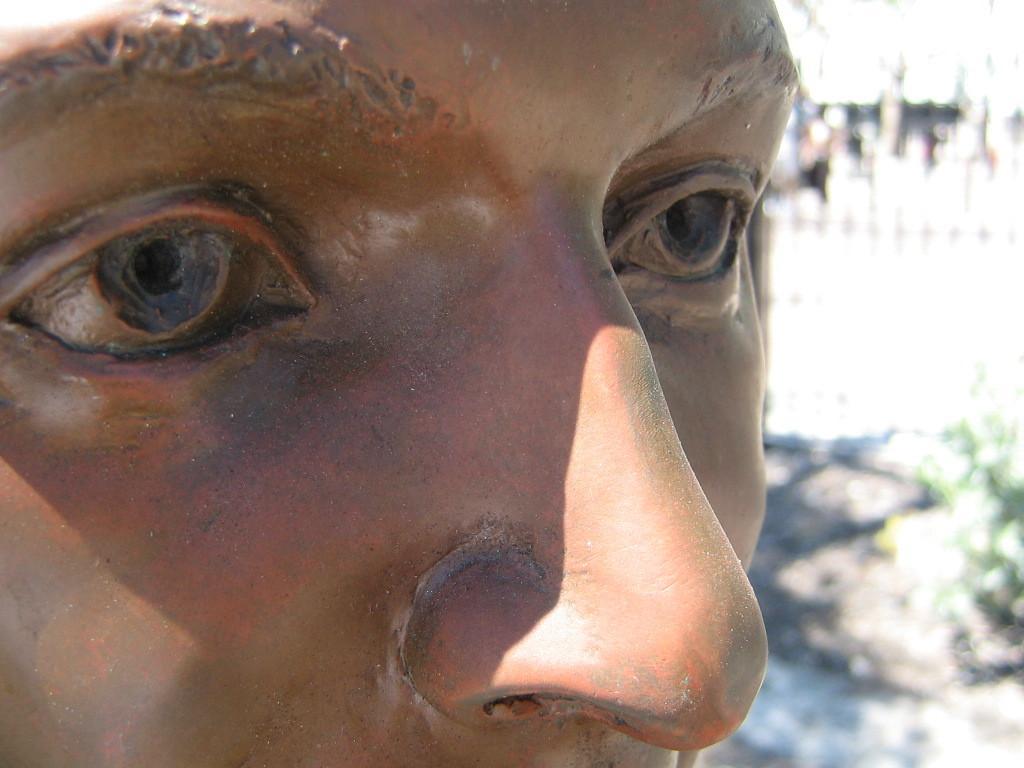Please provide a concise description of this image. In the image we can see a face. Background of the image is blur. 